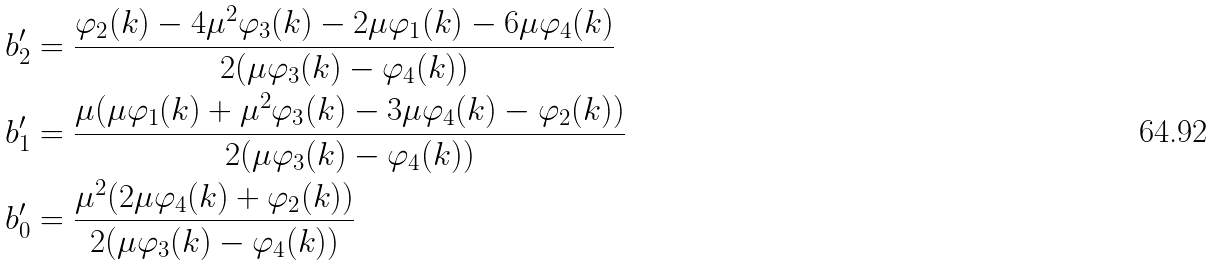<formula> <loc_0><loc_0><loc_500><loc_500>b ^ { \prime } _ { 2 } & = \frac { \varphi _ { 2 } ( k ) - 4 \mu ^ { 2 } \varphi _ { 3 } ( k ) - 2 \mu \varphi _ { 1 } ( k ) - 6 \mu \varphi _ { 4 } ( k ) } { 2 ( \mu \varphi _ { 3 } ( k ) - \varphi _ { 4 } ( k ) ) } \\ b ^ { \prime } _ { 1 } & = \frac { \mu ( \mu \varphi _ { 1 } ( k ) + \mu ^ { 2 } \varphi _ { 3 } ( k ) - 3 \mu \varphi _ { 4 } ( k ) - \varphi _ { 2 } ( k ) ) } { 2 ( \mu \varphi _ { 3 } ( k ) - \varphi _ { 4 } ( k ) ) } \\ b ^ { \prime } _ { 0 } & = \frac { \mu ^ { 2 } ( 2 \mu \varphi _ { 4 } ( k ) + \varphi _ { 2 } ( k ) ) } { 2 ( \mu \varphi _ { 3 } ( k ) - \varphi _ { 4 } ( k ) ) } \\</formula> 